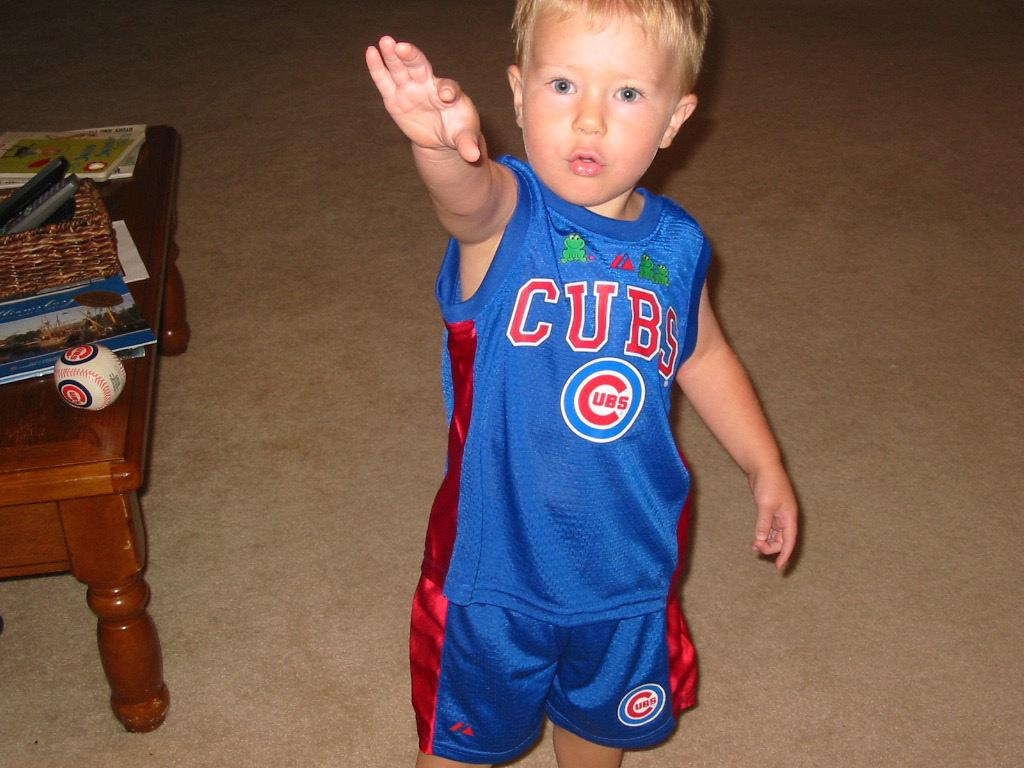<image>
Describe the image concisely. a boy that has a cubs shirt on his back 